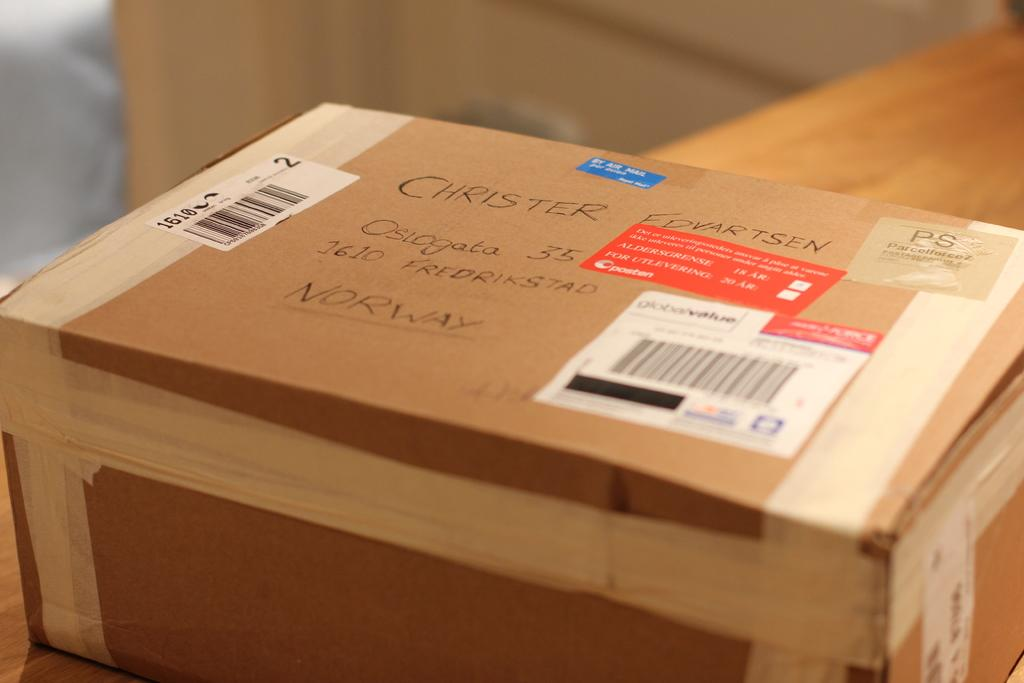<image>
Create a compact narrative representing the image presented. a box addressed to Christer Edvartsen on a table 